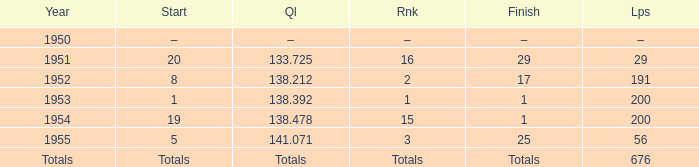What year was the ranking 1? 1953.0. 